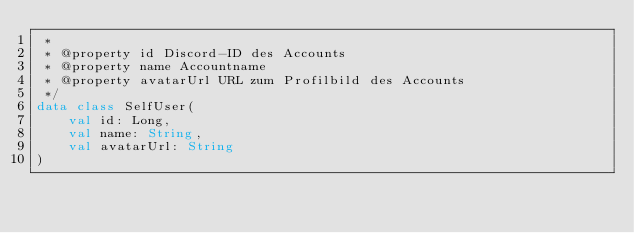Convert code to text. <code><loc_0><loc_0><loc_500><loc_500><_Kotlin_> *
 * @property id Discord-ID des Accounts
 * @property name Accountname
 * @property avatarUrl URL zum Profilbild des Accounts
 */
data class SelfUser(
    val id: Long,
    val name: String,
    val avatarUrl: String
)
</code> 